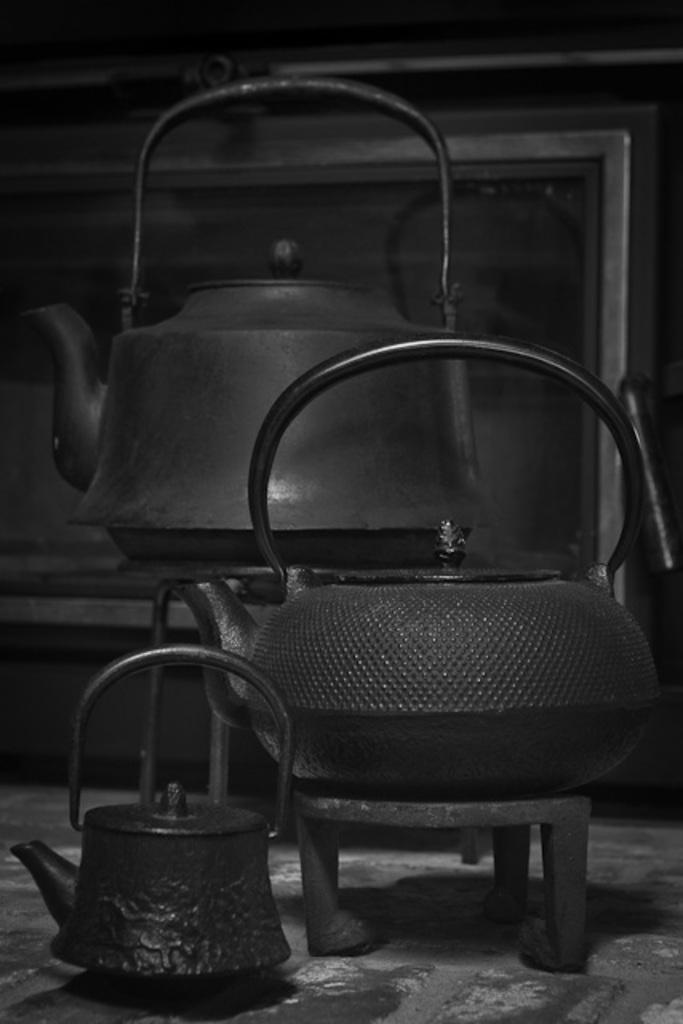How would you summarize this image in a sentence or two? In this image there are kettles which are black in colour. 